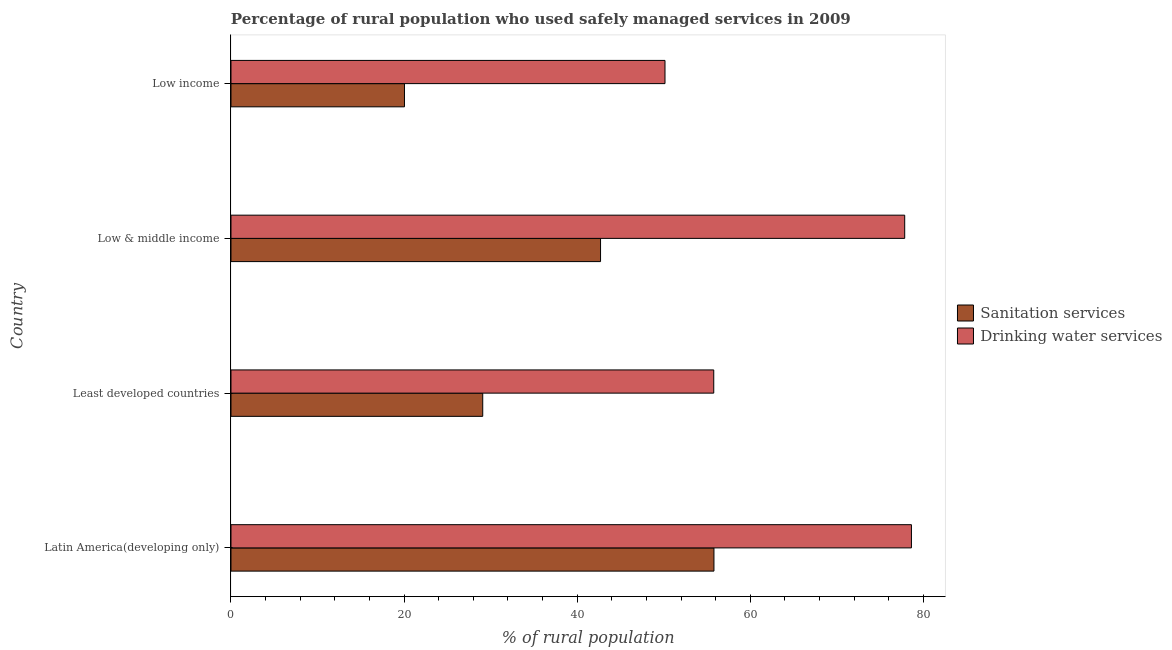What is the label of the 1st group of bars from the top?
Provide a succinct answer. Low income. In how many cases, is the number of bars for a given country not equal to the number of legend labels?
Keep it short and to the point. 0. What is the percentage of rural population who used drinking water services in Least developed countries?
Give a very brief answer. 55.77. Across all countries, what is the maximum percentage of rural population who used drinking water services?
Provide a short and direct response. 78.61. Across all countries, what is the minimum percentage of rural population who used drinking water services?
Offer a very short reply. 50.14. In which country was the percentage of rural population who used sanitation services maximum?
Give a very brief answer. Latin America(developing only). What is the total percentage of rural population who used drinking water services in the graph?
Offer a terse response. 262.36. What is the difference between the percentage of rural population who used drinking water services in Least developed countries and that in Low income?
Your answer should be compact. 5.63. What is the difference between the percentage of rural population who used drinking water services in Latin America(developing only) and the percentage of rural population who used sanitation services in Low income?
Offer a terse response. 58.57. What is the average percentage of rural population who used drinking water services per country?
Offer a terse response. 65.59. What is the difference between the percentage of rural population who used drinking water services and percentage of rural population who used sanitation services in Low & middle income?
Your answer should be very brief. 35.14. What is the ratio of the percentage of rural population who used drinking water services in Latin America(developing only) to that in Low & middle income?
Your answer should be compact. 1.01. Is the percentage of rural population who used drinking water services in Low & middle income less than that in Low income?
Make the answer very short. No. Is the difference between the percentage of rural population who used sanitation services in Latin America(developing only) and Least developed countries greater than the difference between the percentage of rural population who used drinking water services in Latin America(developing only) and Least developed countries?
Make the answer very short. Yes. What is the difference between the highest and the second highest percentage of rural population who used drinking water services?
Keep it short and to the point. 0.78. What is the difference between the highest and the lowest percentage of rural population who used sanitation services?
Your response must be concise. 35.75. In how many countries, is the percentage of rural population who used sanitation services greater than the average percentage of rural population who used sanitation services taken over all countries?
Keep it short and to the point. 2. What does the 1st bar from the top in Least developed countries represents?
Keep it short and to the point. Drinking water services. What does the 1st bar from the bottom in Latin America(developing only) represents?
Your answer should be compact. Sanitation services. How many bars are there?
Offer a very short reply. 8. Are all the bars in the graph horizontal?
Your response must be concise. Yes. How many countries are there in the graph?
Give a very brief answer. 4. What is the title of the graph?
Your response must be concise. Percentage of rural population who used safely managed services in 2009. What is the label or title of the X-axis?
Offer a very short reply. % of rural population. What is the % of rural population of Sanitation services in Latin America(developing only)?
Make the answer very short. 55.8. What is the % of rural population of Drinking water services in Latin America(developing only)?
Provide a short and direct response. 78.61. What is the % of rural population in Sanitation services in Least developed countries?
Offer a terse response. 29.09. What is the % of rural population in Drinking water services in Least developed countries?
Offer a terse response. 55.77. What is the % of rural population of Sanitation services in Low & middle income?
Ensure brevity in your answer.  42.7. What is the % of rural population of Drinking water services in Low & middle income?
Make the answer very short. 77.83. What is the % of rural population in Sanitation services in Low income?
Keep it short and to the point. 20.04. What is the % of rural population in Drinking water services in Low income?
Provide a succinct answer. 50.14. Across all countries, what is the maximum % of rural population in Sanitation services?
Provide a succinct answer. 55.8. Across all countries, what is the maximum % of rural population in Drinking water services?
Your answer should be very brief. 78.61. Across all countries, what is the minimum % of rural population of Sanitation services?
Give a very brief answer. 20.04. Across all countries, what is the minimum % of rural population of Drinking water services?
Make the answer very short. 50.14. What is the total % of rural population in Sanitation services in the graph?
Your answer should be very brief. 147.62. What is the total % of rural population in Drinking water services in the graph?
Keep it short and to the point. 262.36. What is the difference between the % of rural population in Sanitation services in Latin America(developing only) and that in Least developed countries?
Your answer should be very brief. 26.71. What is the difference between the % of rural population of Drinking water services in Latin America(developing only) and that in Least developed countries?
Your answer should be very brief. 22.84. What is the difference between the % of rural population of Sanitation services in Latin America(developing only) and that in Low & middle income?
Your answer should be very brief. 13.1. What is the difference between the % of rural population of Drinking water services in Latin America(developing only) and that in Low & middle income?
Provide a succinct answer. 0.78. What is the difference between the % of rural population of Sanitation services in Latin America(developing only) and that in Low income?
Your answer should be compact. 35.75. What is the difference between the % of rural population of Drinking water services in Latin America(developing only) and that in Low income?
Offer a terse response. 28.47. What is the difference between the % of rural population in Sanitation services in Least developed countries and that in Low & middle income?
Your answer should be compact. -13.61. What is the difference between the % of rural population in Drinking water services in Least developed countries and that in Low & middle income?
Provide a succinct answer. -22.06. What is the difference between the % of rural population in Sanitation services in Least developed countries and that in Low income?
Provide a succinct answer. 9.04. What is the difference between the % of rural population in Drinking water services in Least developed countries and that in Low income?
Your response must be concise. 5.63. What is the difference between the % of rural population of Sanitation services in Low & middle income and that in Low income?
Ensure brevity in your answer.  22.65. What is the difference between the % of rural population of Drinking water services in Low & middle income and that in Low income?
Ensure brevity in your answer.  27.69. What is the difference between the % of rural population of Sanitation services in Latin America(developing only) and the % of rural population of Drinking water services in Least developed countries?
Offer a very short reply. 0.02. What is the difference between the % of rural population of Sanitation services in Latin America(developing only) and the % of rural population of Drinking water services in Low & middle income?
Make the answer very short. -22.04. What is the difference between the % of rural population of Sanitation services in Latin America(developing only) and the % of rural population of Drinking water services in Low income?
Ensure brevity in your answer.  5.65. What is the difference between the % of rural population of Sanitation services in Least developed countries and the % of rural population of Drinking water services in Low & middle income?
Your answer should be very brief. -48.75. What is the difference between the % of rural population in Sanitation services in Least developed countries and the % of rural population in Drinking water services in Low income?
Your response must be concise. -21.06. What is the difference between the % of rural population of Sanitation services in Low & middle income and the % of rural population of Drinking water services in Low income?
Your answer should be compact. -7.45. What is the average % of rural population in Sanitation services per country?
Your answer should be compact. 36.91. What is the average % of rural population in Drinking water services per country?
Provide a short and direct response. 65.59. What is the difference between the % of rural population in Sanitation services and % of rural population in Drinking water services in Latin America(developing only)?
Your answer should be compact. -22.82. What is the difference between the % of rural population in Sanitation services and % of rural population in Drinking water services in Least developed countries?
Provide a short and direct response. -26.69. What is the difference between the % of rural population of Sanitation services and % of rural population of Drinking water services in Low & middle income?
Make the answer very short. -35.14. What is the difference between the % of rural population in Sanitation services and % of rural population in Drinking water services in Low income?
Make the answer very short. -30.1. What is the ratio of the % of rural population in Sanitation services in Latin America(developing only) to that in Least developed countries?
Offer a very short reply. 1.92. What is the ratio of the % of rural population in Drinking water services in Latin America(developing only) to that in Least developed countries?
Your answer should be very brief. 1.41. What is the ratio of the % of rural population in Sanitation services in Latin America(developing only) to that in Low & middle income?
Provide a short and direct response. 1.31. What is the ratio of the % of rural population in Sanitation services in Latin America(developing only) to that in Low income?
Provide a short and direct response. 2.78. What is the ratio of the % of rural population in Drinking water services in Latin America(developing only) to that in Low income?
Offer a terse response. 1.57. What is the ratio of the % of rural population in Sanitation services in Least developed countries to that in Low & middle income?
Offer a very short reply. 0.68. What is the ratio of the % of rural population of Drinking water services in Least developed countries to that in Low & middle income?
Ensure brevity in your answer.  0.72. What is the ratio of the % of rural population of Sanitation services in Least developed countries to that in Low income?
Keep it short and to the point. 1.45. What is the ratio of the % of rural population of Drinking water services in Least developed countries to that in Low income?
Your answer should be compact. 1.11. What is the ratio of the % of rural population of Sanitation services in Low & middle income to that in Low income?
Provide a short and direct response. 2.13. What is the ratio of the % of rural population of Drinking water services in Low & middle income to that in Low income?
Offer a terse response. 1.55. What is the difference between the highest and the second highest % of rural population in Sanitation services?
Your answer should be very brief. 13.1. What is the difference between the highest and the second highest % of rural population of Drinking water services?
Give a very brief answer. 0.78. What is the difference between the highest and the lowest % of rural population of Sanitation services?
Offer a very short reply. 35.75. What is the difference between the highest and the lowest % of rural population in Drinking water services?
Offer a terse response. 28.47. 